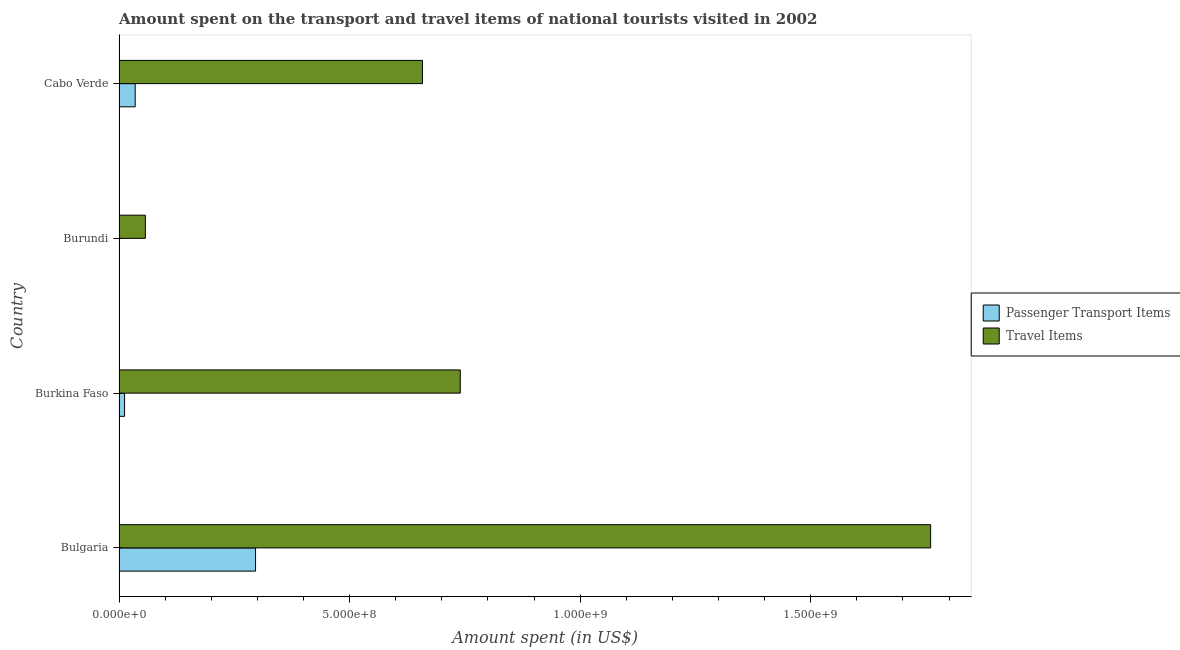What is the label of the 3rd group of bars from the top?
Keep it short and to the point. Burkina Faso. Across all countries, what is the maximum amount spent in travel items?
Provide a short and direct response. 1.76e+09. Across all countries, what is the minimum amount spent in travel items?
Your response must be concise. 5.70e+07. In which country was the amount spent in travel items maximum?
Give a very brief answer. Bulgaria. In which country was the amount spent on passenger transport items minimum?
Ensure brevity in your answer.  Burundi. What is the total amount spent in travel items in the graph?
Make the answer very short. 3.22e+09. What is the difference between the amount spent in travel items in Bulgaria and that in Burkina Faso?
Your answer should be compact. 1.02e+09. What is the difference between the amount spent in travel items in Bulgaria and the amount spent on passenger transport items in Cabo Verde?
Provide a succinct answer. 1.72e+09. What is the average amount spent in travel items per country?
Provide a succinct answer. 8.04e+08. What is the difference between the amount spent in travel items and amount spent on passenger transport items in Burkina Faso?
Offer a very short reply. 7.28e+08. What is the ratio of the amount spent in travel items in Bulgaria to that in Burundi?
Your answer should be compact. 30.88. What is the difference between the highest and the second highest amount spent on passenger transport items?
Offer a very short reply. 2.61e+08. What is the difference between the highest and the lowest amount spent on passenger transport items?
Provide a short and direct response. 2.96e+08. Is the sum of the amount spent on passenger transport items in Bulgaria and Burundi greater than the maximum amount spent in travel items across all countries?
Your answer should be very brief. No. What does the 2nd bar from the top in Bulgaria represents?
Your answer should be compact. Passenger Transport Items. What does the 2nd bar from the bottom in Burkina Faso represents?
Your answer should be compact. Travel Items. How many bars are there?
Offer a very short reply. 8. What is the difference between two consecutive major ticks on the X-axis?
Offer a terse response. 5.00e+08. Does the graph contain any zero values?
Your response must be concise. No. Where does the legend appear in the graph?
Your answer should be very brief. Center right. How many legend labels are there?
Your answer should be very brief. 2. What is the title of the graph?
Your answer should be very brief. Amount spent on the transport and travel items of national tourists visited in 2002. What is the label or title of the X-axis?
Give a very brief answer. Amount spent (in US$). What is the label or title of the Y-axis?
Give a very brief answer. Country. What is the Amount spent (in US$) in Passenger Transport Items in Bulgaria?
Make the answer very short. 2.96e+08. What is the Amount spent (in US$) of Travel Items in Bulgaria?
Offer a terse response. 1.76e+09. What is the Amount spent (in US$) of Travel Items in Burkina Faso?
Provide a succinct answer. 7.40e+08. What is the Amount spent (in US$) in Passenger Transport Items in Burundi?
Offer a terse response. 5.00e+05. What is the Amount spent (in US$) of Travel Items in Burundi?
Your answer should be very brief. 5.70e+07. What is the Amount spent (in US$) of Passenger Transport Items in Cabo Verde?
Your answer should be compact. 3.50e+07. What is the Amount spent (in US$) of Travel Items in Cabo Verde?
Ensure brevity in your answer.  6.58e+08. Across all countries, what is the maximum Amount spent (in US$) in Passenger Transport Items?
Your response must be concise. 2.96e+08. Across all countries, what is the maximum Amount spent (in US$) of Travel Items?
Your answer should be compact. 1.76e+09. Across all countries, what is the minimum Amount spent (in US$) in Passenger Transport Items?
Offer a terse response. 5.00e+05. Across all countries, what is the minimum Amount spent (in US$) in Travel Items?
Keep it short and to the point. 5.70e+07. What is the total Amount spent (in US$) in Passenger Transport Items in the graph?
Provide a short and direct response. 3.44e+08. What is the total Amount spent (in US$) of Travel Items in the graph?
Your answer should be compact. 3.22e+09. What is the difference between the Amount spent (in US$) in Passenger Transport Items in Bulgaria and that in Burkina Faso?
Your response must be concise. 2.84e+08. What is the difference between the Amount spent (in US$) in Travel Items in Bulgaria and that in Burkina Faso?
Provide a short and direct response. 1.02e+09. What is the difference between the Amount spent (in US$) of Passenger Transport Items in Bulgaria and that in Burundi?
Keep it short and to the point. 2.96e+08. What is the difference between the Amount spent (in US$) of Travel Items in Bulgaria and that in Burundi?
Your answer should be compact. 1.70e+09. What is the difference between the Amount spent (in US$) in Passenger Transport Items in Bulgaria and that in Cabo Verde?
Keep it short and to the point. 2.61e+08. What is the difference between the Amount spent (in US$) in Travel Items in Bulgaria and that in Cabo Verde?
Provide a short and direct response. 1.10e+09. What is the difference between the Amount spent (in US$) in Passenger Transport Items in Burkina Faso and that in Burundi?
Provide a succinct answer. 1.15e+07. What is the difference between the Amount spent (in US$) of Travel Items in Burkina Faso and that in Burundi?
Your answer should be compact. 6.83e+08. What is the difference between the Amount spent (in US$) in Passenger Transport Items in Burkina Faso and that in Cabo Verde?
Provide a succinct answer. -2.30e+07. What is the difference between the Amount spent (in US$) of Travel Items in Burkina Faso and that in Cabo Verde?
Your response must be concise. 8.20e+07. What is the difference between the Amount spent (in US$) in Passenger Transport Items in Burundi and that in Cabo Verde?
Keep it short and to the point. -3.45e+07. What is the difference between the Amount spent (in US$) of Travel Items in Burundi and that in Cabo Verde?
Give a very brief answer. -6.01e+08. What is the difference between the Amount spent (in US$) of Passenger Transport Items in Bulgaria and the Amount spent (in US$) of Travel Items in Burkina Faso?
Provide a short and direct response. -4.44e+08. What is the difference between the Amount spent (in US$) in Passenger Transport Items in Bulgaria and the Amount spent (in US$) in Travel Items in Burundi?
Ensure brevity in your answer.  2.39e+08. What is the difference between the Amount spent (in US$) of Passenger Transport Items in Bulgaria and the Amount spent (in US$) of Travel Items in Cabo Verde?
Offer a very short reply. -3.62e+08. What is the difference between the Amount spent (in US$) of Passenger Transport Items in Burkina Faso and the Amount spent (in US$) of Travel Items in Burundi?
Provide a succinct answer. -4.50e+07. What is the difference between the Amount spent (in US$) in Passenger Transport Items in Burkina Faso and the Amount spent (in US$) in Travel Items in Cabo Verde?
Provide a short and direct response. -6.46e+08. What is the difference between the Amount spent (in US$) of Passenger Transport Items in Burundi and the Amount spent (in US$) of Travel Items in Cabo Verde?
Your answer should be compact. -6.58e+08. What is the average Amount spent (in US$) of Passenger Transport Items per country?
Offer a terse response. 8.59e+07. What is the average Amount spent (in US$) in Travel Items per country?
Your answer should be compact. 8.04e+08. What is the difference between the Amount spent (in US$) of Passenger Transport Items and Amount spent (in US$) of Travel Items in Bulgaria?
Your answer should be compact. -1.46e+09. What is the difference between the Amount spent (in US$) in Passenger Transport Items and Amount spent (in US$) in Travel Items in Burkina Faso?
Make the answer very short. -7.28e+08. What is the difference between the Amount spent (in US$) in Passenger Transport Items and Amount spent (in US$) in Travel Items in Burundi?
Provide a succinct answer. -5.65e+07. What is the difference between the Amount spent (in US$) in Passenger Transport Items and Amount spent (in US$) in Travel Items in Cabo Verde?
Offer a terse response. -6.23e+08. What is the ratio of the Amount spent (in US$) of Passenger Transport Items in Bulgaria to that in Burkina Faso?
Keep it short and to the point. 24.67. What is the ratio of the Amount spent (in US$) of Travel Items in Bulgaria to that in Burkina Faso?
Ensure brevity in your answer.  2.38. What is the ratio of the Amount spent (in US$) of Passenger Transport Items in Bulgaria to that in Burundi?
Your response must be concise. 592. What is the ratio of the Amount spent (in US$) in Travel Items in Bulgaria to that in Burundi?
Your response must be concise. 30.88. What is the ratio of the Amount spent (in US$) of Passenger Transport Items in Bulgaria to that in Cabo Verde?
Make the answer very short. 8.46. What is the ratio of the Amount spent (in US$) of Travel Items in Bulgaria to that in Cabo Verde?
Keep it short and to the point. 2.67. What is the ratio of the Amount spent (in US$) in Travel Items in Burkina Faso to that in Burundi?
Give a very brief answer. 12.98. What is the ratio of the Amount spent (in US$) of Passenger Transport Items in Burkina Faso to that in Cabo Verde?
Provide a short and direct response. 0.34. What is the ratio of the Amount spent (in US$) of Travel Items in Burkina Faso to that in Cabo Verde?
Offer a very short reply. 1.12. What is the ratio of the Amount spent (in US$) in Passenger Transport Items in Burundi to that in Cabo Verde?
Make the answer very short. 0.01. What is the ratio of the Amount spent (in US$) in Travel Items in Burundi to that in Cabo Verde?
Give a very brief answer. 0.09. What is the difference between the highest and the second highest Amount spent (in US$) of Passenger Transport Items?
Give a very brief answer. 2.61e+08. What is the difference between the highest and the second highest Amount spent (in US$) in Travel Items?
Your answer should be compact. 1.02e+09. What is the difference between the highest and the lowest Amount spent (in US$) of Passenger Transport Items?
Provide a short and direct response. 2.96e+08. What is the difference between the highest and the lowest Amount spent (in US$) of Travel Items?
Your answer should be compact. 1.70e+09. 